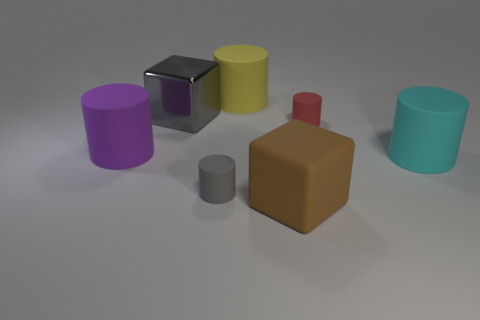Is there any other thing that is the same shape as the big yellow rubber object?
Provide a short and direct response. Yes. There is another matte object that is the same shape as the big gray object; what is its color?
Keep it short and to the point. Brown. Do the rubber cube and the tiny thing that is behind the cyan cylinder have the same color?
Ensure brevity in your answer.  No. The rubber object that is left of the big yellow matte thing and behind the cyan cylinder has what shape?
Provide a short and direct response. Cylinder. Are there fewer brown matte blocks than big green things?
Provide a succinct answer. No. Are there any green rubber balls?
Keep it short and to the point. No. How many other objects are there of the same size as the purple matte cylinder?
Offer a terse response. 4. Are the small red cylinder and the block that is behind the brown rubber object made of the same material?
Offer a very short reply. No. Is the number of small gray objects that are behind the large yellow rubber thing the same as the number of small red matte things that are on the right side of the cyan rubber thing?
Your answer should be very brief. Yes. What material is the big cyan thing?
Your answer should be compact. Rubber. 